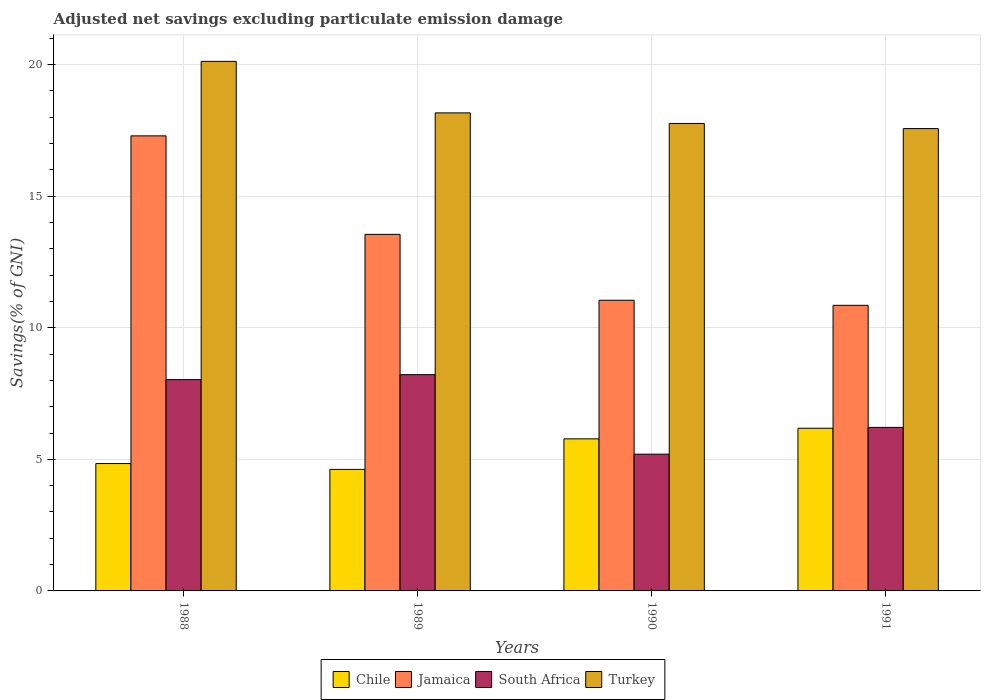Are the number of bars per tick equal to the number of legend labels?
Your response must be concise. Yes. Are the number of bars on each tick of the X-axis equal?
Your answer should be very brief. Yes. How many bars are there on the 3rd tick from the left?
Your answer should be very brief. 4. How many bars are there on the 4th tick from the right?
Make the answer very short. 4. What is the label of the 1st group of bars from the left?
Offer a very short reply. 1988. In how many cases, is the number of bars for a given year not equal to the number of legend labels?
Your answer should be compact. 0. What is the adjusted net savings in Jamaica in 1990?
Make the answer very short. 11.05. Across all years, what is the maximum adjusted net savings in Chile?
Offer a very short reply. 6.18. Across all years, what is the minimum adjusted net savings in Chile?
Ensure brevity in your answer.  4.62. What is the total adjusted net savings in Jamaica in the graph?
Give a very brief answer. 52.74. What is the difference between the adjusted net savings in Jamaica in 1989 and that in 1991?
Your answer should be compact. 2.7. What is the difference between the adjusted net savings in South Africa in 1988 and the adjusted net savings in Chile in 1991?
Your answer should be very brief. 1.85. What is the average adjusted net savings in South Africa per year?
Provide a succinct answer. 6.91. In the year 1990, what is the difference between the adjusted net savings in Chile and adjusted net savings in Jamaica?
Provide a succinct answer. -5.27. What is the ratio of the adjusted net savings in Turkey in 1988 to that in 1989?
Offer a very short reply. 1.11. Is the adjusted net savings in Jamaica in 1988 less than that in 1991?
Give a very brief answer. No. What is the difference between the highest and the second highest adjusted net savings in Jamaica?
Offer a terse response. 3.74. What is the difference between the highest and the lowest adjusted net savings in Turkey?
Offer a very short reply. 2.55. In how many years, is the adjusted net savings in Jamaica greater than the average adjusted net savings in Jamaica taken over all years?
Offer a terse response. 2. Is the sum of the adjusted net savings in Turkey in 1990 and 1991 greater than the maximum adjusted net savings in South Africa across all years?
Your answer should be compact. Yes. What does the 4th bar from the left in 1989 represents?
Your answer should be compact. Turkey. What does the 3rd bar from the right in 1988 represents?
Your response must be concise. Jamaica. How many bars are there?
Ensure brevity in your answer.  16. Are all the bars in the graph horizontal?
Ensure brevity in your answer.  No. How many years are there in the graph?
Make the answer very short. 4. What is the difference between two consecutive major ticks on the Y-axis?
Your response must be concise. 5. How many legend labels are there?
Provide a succinct answer. 4. How are the legend labels stacked?
Ensure brevity in your answer.  Horizontal. What is the title of the graph?
Give a very brief answer. Adjusted net savings excluding particulate emission damage. Does "Kyrgyz Republic" appear as one of the legend labels in the graph?
Your response must be concise. No. What is the label or title of the Y-axis?
Ensure brevity in your answer.  Savings(% of GNI). What is the Savings(% of GNI) in Chile in 1988?
Your response must be concise. 4.84. What is the Savings(% of GNI) of Jamaica in 1988?
Your response must be concise. 17.29. What is the Savings(% of GNI) of South Africa in 1988?
Provide a short and direct response. 8.03. What is the Savings(% of GNI) of Turkey in 1988?
Provide a succinct answer. 20.12. What is the Savings(% of GNI) of Chile in 1989?
Ensure brevity in your answer.  4.62. What is the Savings(% of GNI) of Jamaica in 1989?
Keep it short and to the point. 13.55. What is the Savings(% of GNI) of South Africa in 1989?
Your answer should be compact. 8.22. What is the Savings(% of GNI) in Turkey in 1989?
Provide a succinct answer. 18.17. What is the Savings(% of GNI) of Chile in 1990?
Your answer should be compact. 5.78. What is the Savings(% of GNI) in Jamaica in 1990?
Provide a short and direct response. 11.05. What is the Savings(% of GNI) of South Africa in 1990?
Keep it short and to the point. 5.2. What is the Savings(% of GNI) of Turkey in 1990?
Provide a short and direct response. 17.76. What is the Savings(% of GNI) of Chile in 1991?
Your answer should be very brief. 6.18. What is the Savings(% of GNI) in Jamaica in 1991?
Make the answer very short. 10.85. What is the Savings(% of GNI) of South Africa in 1991?
Offer a terse response. 6.21. What is the Savings(% of GNI) in Turkey in 1991?
Keep it short and to the point. 17.57. Across all years, what is the maximum Savings(% of GNI) in Chile?
Provide a succinct answer. 6.18. Across all years, what is the maximum Savings(% of GNI) in Jamaica?
Provide a succinct answer. 17.29. Across all years, what is the maximum Savings(% of GNI) of South Africa?
Your response must be concise. 8.22. Across all years, what is the maximum Savings(% of GNI) in Turkey?
Your response must be concise. 20.12. Across all years, what is the minimum Savings(% of GNI) in Chile?
Keep it short and to the point. 4.62. Across all years, what is the minimum Savings(% of GNI) in Jamaica?
Provide a succinct answer. 10.85. Across all years, what is the minimum Savings(% of GNI) of South Africa?
Your answer should be very brief. 5.2. Across all years, what is the minimum Savings(% of GNI) in Turkey?
Make the answer very short. 17.57. What is the total Savings(% of GNI) of Chile in the graph?
Offer a very short reply. 21.42. What is the total Savings(% of GNI) of Jamaica in the graph?
Provide a succinct answer. 52.74. What is the total Savings(% of GNI) of South Africa in the graph?
Keep it short and to the point. 27.66. What is the total Savings(% of GNI) of Turkey in the graph?
Offer a very short reply. 73.63. What is the difference between the Savings(% of GNI) of Chile in 1988 and that in 1989?
Give a very brief answer. 0.22. What is the difference between the Savings(% of GNI) in Jamaica in 1988 and that in 1989?
Make the answer very short. 3.74. What is the difference between the Savings(% of GNI) in South Africa in 1988 and that in 1989?
Keep it short and to the point. -0.19. What is the difference between the Savings(% of GNI) of Turkey in 1988 and that in 1989?
Give a very brief answer. 1.96. What is the difference between the Savings(% of GNI) of Chile in 1988 and that in 1990?
Make the answer very short. -0.94. What is the difference between the Savings(% of GNI) in Jamaica in 1988 and that in 1990?
Give a very brief answer. 6.25. What is the difference between the Savings(% of GNI) in South Africa in 1988 and that in 1990?
Ensure brevity in your answer.  2.83. What is the difference between the Savings(% of GNI) of Turkey in 1988 and that in 1990?
Your answer should be compact. 2.36. What is the difference between the Savings(% of GNI) in Chile in 1988 and that in 1991?
Make the answer very short. -1.34. What is the difference between the Savings(% of GNI) of Jamaica in 1988 and that in 1991?
Keep it short and to the point. 6.44. What is the difference between the Savings(% of GNI) of South Africa in 1988 and that in 1991?
Provide a succinct answer. 1.82. What is the difference between the Savings(% of GNI) of Turkey in 1988 and that in 1991?
Keep it short and to the point. 2.55. What is the difference between the Savings(% of GNI) in Chile in 1989 and that in 1990?
Ensure brevity in your answer.  -1.16. What is the difference between the Savings(% of GNI) of Jamaica in 1989 and that in 1990?
Provide a short and direct response. 2.5. What is the difference between the Savings(% of GNI) of South Africa in 1989 and that in 1990?
Offer a very short reply. 3.02. What is the difference between the Savings(% of GNI) in Turkey in 1989 and that in 1990?
Your answer should be very brief. 0.4. What is the difference between the Savings(% of GNI) in Chile in 1989 and that in 1991?
Provide a short and direct response. -1.56. What is the difference between the Savings(% of GNI) in Jamaica in 1989 and that in 1991?
Provide a short and direct response. 2.7. What is the difference between the Savings(% of GNI) in South Africa in 1989 and that in 1991?
Keep it short and to the point. 2. What is the difference between the Savings(% of GNI) of Turkey in 1989 and that in 1991?
Make the answer very short. 0.6. What is the difference between the Savings(% of GNI) in Chile in 1990 and that in 1991?
Your response must be concise. -0.4. What is the difference between the Savings(% of GNI) in Jamaica in 1990 and that in 1991?
Make the answer very short. 0.19. What is the difference between the Savings(% of GNI) in South Africa in 1990 and that in 1991?
Offer a very short reply. -1.02. What is the difference between the Savings(% of GNI) of Turkey in 1990 and that in 1991?
Ensure brevity in your answer.  0.19. What is the difference between the Savings(% of GNI) of Chile in 1988 and the Savings(% of GNI) of Jamaica in 1989?
Give a very brief answer. -8.71. What is the difference between the Savings(% of GNI) in Chile in 1988 and the Savings(% of GNI) in South Africa in 1989?
Ensure brevity in your answer.  -3.38. What is the difference between the Savings(% of GNI) in Chile in 1988 and the Savings(% of GNI) in Turkey in 1989?
Offer a very short reply. -13.33. What is the difference between the Savings(% of GNI) in Jamaica in 1988 and the Savings(% of GNI) in South Africa in 1989?
Keep it short and to the point. 9.07. What is the difference between the Savings(% of GNI) of Jamaica in 1988 and the Savings(% of GNI) of Turkey in 1989?
Make the answer very short. -0.87. What is the difference between the Savings(% of GNI) of South Africa in 1988 and the Savings(% of GNI) of Turkey in 1989?
Your answer should be very brief. -10.14. What is the difference between the Savings(% of GNI) in Chile in 1988 and the Savings(% of GNI) in Jamaica in 1990?
Offer a very short reply. -6.21. What is the difference between the Savings(% of GNI) in Chile in 1988 and the Savings(% of GNI) in South Africa in 1990?
Your answer should be very brief. -0.36. What is the difference between the Savings(% of GNI) of Chile in 1988 and the Savings(% of GNI) of Turkey in 1990?
Your answer should be compact. -12.92. What is the difference between the Savings(% of GNI) in Jamaica in 1988 and the Savings(% of GNI) in South Africa in 1990?
Keep it short and to the point. 12.1. What is the difference between the Savings(% of GNI) of Jamaica in 1988 and the Savings(% of GNI) of Turkey in 1990?
Keep it short and to the point. -0.47. What is the difference between the Savings(% of GNI) of South Africa in 1988 and the Savings(% of GNI) of Turkey in 1990?
Ensure brevity in your answer.  -9.73. What is the difference between the Savings(% of GNI) in Chile in 1988 and the Savings(% of GNI) in Jamaica in 1991?
Offer a very short reply. -6.01. What is the difference between the Savings(% of GNI) of Chile in 1988 and the Savings(% of GNI) of South Africa in 1991?
Provide a succinct answer. -1.37. What is the difference between the Savings(% of GNI) of Chile in 1988 and the Savings(% of GNI) of Turkey in 1991?
Ensure brevity in your answer.  -12.73. What is the difference between the Savings(% of GNI) of Jamaica in 1988 and the Savings(% of GNI) of South Africa in 1991?
Ensure brevity in your answer.  11.08. What is the difference between the Savings(% of GNI) of Jamaica in 1988 and the Savings(% of GNI) of Turkey in 1991?
Keep it short and to the point. -0.28. What is the difference between the Savings(% of GNI) in South Africa in 1988 and the Savings(% of GNI) in Turkey in 1991?
Make the answer very short. -9.54. What is the difference between the Savings(% of GNI) in Chile in 1989 and the Savings(% of GNI) in Jamaica in 1990?
Keep it short and to the point. -6.43. What is the difference between the Savings(% of GNI) in Chile in 1989 and the Savings(% of GNI) in South Africa in 1990?
Offer a terse response. -0.58. What is the difference between the Savings(% of GNI) in Chile in 1989 and the Savings(% of GNI) in Turkey in 1990?
Your response must be concise. -13.15. What is the difference between the Savings(% of GNI) in Jamaica in 1989 and the Savings(% of GNI) in South Africa in 1990?
Offer a terse response. 8.35. What is the difference between the Savings(% of GNI) of Jamaica in 1989 and the Savings(% of GNI) of Turkey in 1990?
Your answer should be very brief. -4.21. What is the difference between the Savings(% of GNI) of South Africa in 1989 and the Savings(% of GNI) of Turkey in 1990?
Your answer should be very brief. -9.55. What is the difference between the Savings(% of GNI) of Chile in 1989 and the Savings(% of GNI) of Jamaica in 1991?
Provide a short and direct response. -6.24. What is the difference between the Savings(% of GNI) of Chile in 1989 and the Savings(% of GNI) of South Africa in 1991?
Ensure brevity in your answer.  -1.6. What is the difference between the Savings(% of GNI) of Chile in 1989 and the Savings(% of GNI) of Turkey in 1991?
Your answer should be very brief. -12.95. What is the difference between the Savings(% of GNI) in Jamaica in 1989 and the Savings(% of GNI) in South Africa in 1991?
Your answer should be very brief. 7.34. What is the difference between the Savings(% of GNI) in Jamaica in 1989 and the Savings(% of GNI) in Turkey in 1991?
Offer a terse response. -4.02. What is the difference between the Savings(% of GNI) of South Africa in 1989 and the Savings(% of GNI) of Turkey in 1991?
Provide a short and direct response. -9.35. What is the difference between the Savings(% of GNI) of Chile in 1990 and the Savings(% of GNI) of Jamaica in 1991?
Provide a succinct answer. -5.08. What is the difference between the Savings(% of GNI) of Chile in 1990 and the Savings(% of GNI) of South Africa in 1991?
Your response must be concise. -0.44. What is the difference between the Savings(% of GNI) in Chile in 1990 and the Savings(% of GNI) in Turkey in 1991?
Offer a very short reply. -11.79. What is the difference between the Savings(% of GNI) in Jamaica in 1990 and the Savings(% of GNI) in South Africa in 1991?
Your answer should be very brief. 4.83. What is the difference between the Savings(% of GNI) in Jamaica in 1990 and the Savings(% of GNI) in Turkey in 1991?
Your answer should be very brief. -6.52. What is the difference between the Savings(% of GNI) in South Africa in 1990 and the Savings(% of GNI) in Turkey in 1991?
Offer a terse response. -12.37. What is the average Savings(% of GNI) of Chile per year?
Provide a short and direct response. 5.35. What is the average Savings(% of GNI) in Jamaica per year?
Make the answer very short. 13.19. What is the average Savings(% of GNI) in South Africa per year?
Keep it short and to the point. 6.91. What is the average Savings(% of GNI) in Turkey per year?
Provide a succinct answer. 18.41. In the year 1988, what is the difference between the Savings(% of GNI) in Chile and Savings(% of GNI) in Jamaica?
Provide a short and direct response. -12.45. In the year 1988, what is the difference between the Savings(% of GNI) in Chile and Savings(% of GNI) in South Africa?
Ensure brevity in your answer.  -3.19. In the year 1988, what is the difference between the Savings(% of GNI) of Chile and Savings(% of GNI) of Turkey?
Keep it short and to the point. -15.28. In the year 1988, what is the difference between the Savings(% of GNI) in Jamaica and Savings(% of GNI) in South Africa?
Your response must be concise. 9.26. In the year 1988, what is the difference between the Savings(% of GNI) in Jamaica and Savings(% of GNI) in Turkey?
Offer a very short reply. -2.83. In the year 1988, what is the difference between the Savings(% of GNI) in South Africa and Savings(% of GNI) in Turkey?
Your response must be concise. -12.1. In the year 1989, what is the difference between the Savings(% of GNI) of Chile and Savings(% of GNI) of Jamaica?
Give a very brief answer. -8.93. In the year 1989, what is the difference between the Savings(% of GNI) of Chile and Savings(% of GNI) of South Africa?
Give a very brief answer. -3.6. In the year 1989, what is the difference between the Savings(% of GNI) in Chile and Savings(% of GNI) in Turkey?
Make the answer very short. -13.55. In the year 1989, what is the difference between the Savings(% of GNI) of Jamaica and Savings(% of GNI) of South Africa?
Give a very brief answer. 5.33. In the year 1989, what is the difference between the Savings(% of GNI) in Jamaica and Savings(% of GNI) in Turkey?
Provide a succinct answer. -4.62. In the year 1989, what is the difference between the Savings(% of GNI) of South Africa and Savings(% of GNI) of Turkey?
Provide a succinct answer. -9.95. In the year 1990, what is the difference between the Savings(% of GNI) of Chile and Savings(% of GNI) of Jamaica?
Your answer should be compact. -5.27. In the year 1990, what is the difference between the Savings(% of GNI) of Chile and Savings(% of GNI) of South Africa?
Your answer should be compact. 0.58. In the year 1990, what is the difference between the Savings(% of GNI) of Chile and Savings(% of GNI) of Turkey?
Provide a succinct answer. -11.99. In the year 1990, what is the difference between the Savings(% of GNI) of Jamaica and Savings(% of GNI) of South Africa?
Provide a short and direct response. 5.85. In the year 1990, what is the difference between the Savings(% of GNI) in Jamaica and Savings(% of GNI) in Turkey?
Give a very brief answer. -6.72. In the year 1990, what is the difference between the Savings(% of GNI) of South Africa and Savings(% of GNI) of Turkey?
Ensure brevity in your answer.  -12.57. In the year 1991, what is the difference between the Savings(% of GNI) of Chile and Savings(% of GNI) of Jamaica?
Ensure brevity in your answer.  -4.67. In the year 1991, what is the difference between the Savings(% of GNI) in Chile and Savings(% of GNI) in South Africa?
Ensure brevity in your answer.  -0.03. In the year 1991, what is the difference between the Savings(% of GNI) in Chile and Savings(% of GNI) in Turkey?
Your answer should be very brief. -11.39. In the year 1991, what is the difference between the Savings(% of GNI) in Jamaica and Savings(% of GNI) in South Africa?
Give a very brief answer. 4.64. In the year 1991, what is the difference between the Savings(% of GNI) of Jamaica and Savings(% of GNI) of Turkey?
Keep it short and to the point. -6.72. In the year 1991, what is the difference between the Savings(% of GNI) in South Africa and Savings(% of GNI) in Turkey?
Keep it short and to the point. -11.36. What is the ratio of the Savings(% of GNI) of Chile in 1988 to that in 1989?
Your answer should be compact. 1.05. What is the ratio of the Savings(% of GNI) in Jamaica in 1988 to that in 1989?
Keep it short and to the point. 1.28. What is the ratio of the Savings(% of GNI) in Turkey in 1988 to that in 1989?
Offer a terse response. 1.11. What is the ratio of the Savings(% of GNI) of Chile in 1988 to that in 1990?
Provide a short and direct response. 0.84. What is the ratio of the Savings(% of GNI) of Jamaica in 1988 to that in 1990?
Provide a succinct answer. 1.57. What is the ratio of the Savings(% of GNI) in South Africa in 1988 to that in 1990?
Offer a very short reply. 1.54. What is the ratio of the Savings(% of GNI) of Turkey in 1988 to that in 1990?
Your answer should be very brief. 1.13. What is the ratio of the Savings(% of GNI) in Chile in 1988 to that in 1991?
Your answer should be compact. 0.78. What is the ratio of the Savings(% of GNI) of Jamaica in 1988 to that in 1991?
Your answer should be very brief. 1.59. What is the ratio of the Savings(% of GNI) of South Africa in 1988 to that in 1991?
Your answer should be very brief. 1.29. What is the ratio of the Savings(% of GNI) of Turkey in 1988 to that in 1991?
Ensure brevity in your answer.  1.15. What is the ratio of the Savings(% of GNI) in Chile in 1989 to that in 1990?
Keep it short and to the point. 0.8. What is the ratio of the Savings(% of GNI) of Jamaica in 1989 to that in 1990?
Provide a succinct answer. 1.23. What is the ratio of the Savings(% of GNI) of South Africa in 1989 to that in 1990?
Your answer should be compact. 1.58. What is the ratio of the Savings(% of GNI) of Turkey in 1989 to that in 1990?
Your answer should be very brief. 1.02. What is the ratio of the Savings(% of GNI) in Chile in 1989 to that in 1991?
Give a very brief answer. 0.75. What is the ratio of the Savings(% of GNI) of Jamaica in 1989 to that in 1991?
Your answer should be compact. 1.25. What is the ratio of the Savings(% of GNI) in South Africa in 1989 to that in 1991?
Offer a terse response. 1.32. What is the ratio of the Savings(% of GNI) in Turkey in 1989 to that in 1991?
Offer a terse response. 1.03. What is the ratio of the Savings(% of GNI) in Chile in 1990 to that in 1991?
Your answer should be very brief. 0.93. What is the ratio of the Savings(% of GNI) in Jamaica in 1990 to that in 1991?
Your answer should be very brief. 1.02. What is the ratio of the Savings(% of GNI) in South Africa in 1990 to that in 1991?
Make the answer very short. 0.84. What is the difference between the highest and the second highest Savings(% of GNI) of Chile?
Your response must be concise. 0.4. What is the difference between the highest and the second highest Savings(% of GNI) of Jamaica?
Your answer should be compact. 3.74. What is the difference between the highest and the second highest Savings(% of GNI) in South Africa?
Your answer should be compact. 0.19. What is the difference between the highest and the second highest Savings(% of GNI) of Turkey?
Offer a very short reply. 1.96. What is the difference between the highest and the lowest Savings(% of GNI) of Chile?
Keep it short and to the point. 1.56. What is the difference between the highest and the lowest Savings(% of GNI) in Jamaica?
Ensure brevity in your answer.  6.44. What is the difference between the highest and the lowest Savings(% of GNI) in South Africa?
Provide a succinct answer. 3.02. What is the difference between the highest and the lowest Savings(% of GNI) in Turkey?
Ensure brevity in your answer.  2.55. 